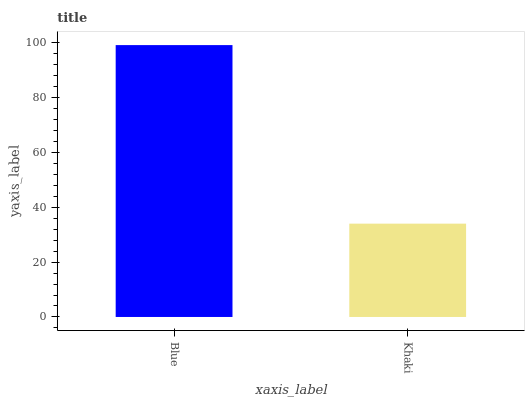Is Khaki the minimum?
Answer yes or no. Yes. Is Blue the maximum?
Answer yes or no. Yes. Is Khaki the maximum?
Answer yes or no. No. Is Blue greater than Khaki?
Answer yes or no. Yes. Is Khaki less than Blue?
Answer yes or no. Yes. Is Khaki greater than Blue?
Answer yes or no. No. Is Blue less than Khaki?
Answer yes or no. No. Is Blue the high median?
Answer yes or no. Yes. Is Khaki the low median?
Answer yes or no. Yes. Is Khaki the high median?
Answer yes or no. No. Is Blue the low median?
Answer yes or no. No. 